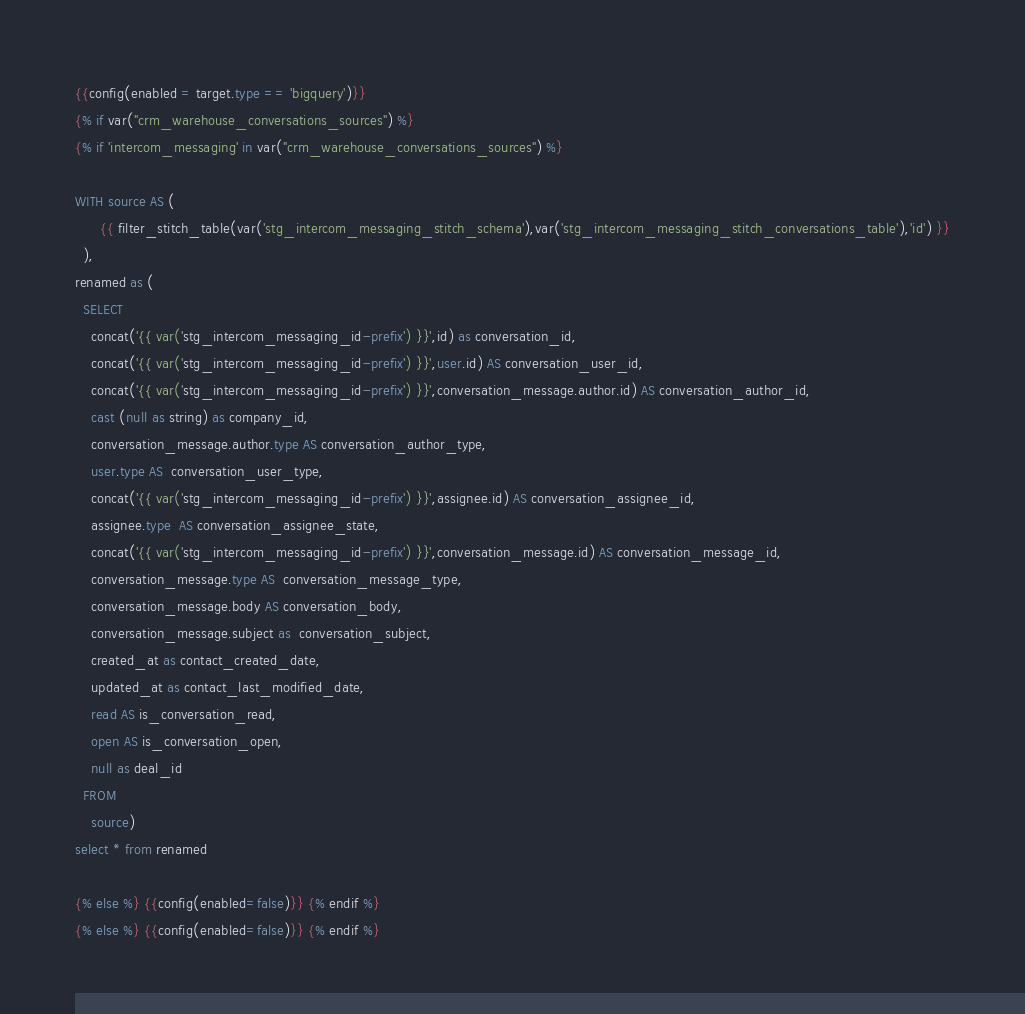Convert code to text. <code><loc_0><loc_0><loc_500><loc_500><_SQL_>{{config(enabled = target.type == 'bigquery')}}
{% if var("crm_warehouse_conversations_sources") %}
{% if 'intercom_messaging' in var("crm_warehouse_conversations_sources") %}

WITH source AS (
      {{ filter_stitch_table(var('stg_intercom_messaging_stitch_schema'),var('stg_intercom_messaging_stitch_conversations_table'),'id') }}
  ),
renamed as (
  SELECT
    concat('{{ var('stg_intercom_messaging_id-prefix') }}',id) as conversation_id,
    concat('{{ var('stg_intercom_messaging_id-prefix') }}',user.id) AS conversation_user_id,
    concat('{{ var('stg_intercom_messaging_id-prefix') }}',conversation_message.author.id) AS conversation_author_id,
    cast (null as string) as company_id,
    conversation_message.author.type AS conversation_author_type,
    user.type AS  conversation_user_type,
    concat('{{ var('stg_intercom_messaging_id-prefix') }}',assignee.id) AS conversation_assignee_id,
    assignee.type  AS conversation_assignee_state,
    concat('{{ var('stg_intercom_messaging_id-prefix') }}',conversation_message.id) AS conversation_message_id,
    conversation_message.type AS  conversation_message_type,
    conversation_message.body AS conversation_body,
    conversation_message.subject as  conversation_subject,
    created_at as contact_created_date,
    updated_at as contact_last_modified_date,
    read AS is_conversation_read,
    open AS is_conversation_open,
    null as deal_id
  FROM
    source)
select * from renamed

{% else %} {{config(enabled=false)}} {% endif %}
{% else %} {{config(enabled=false)}} {% endif %}
</code> 